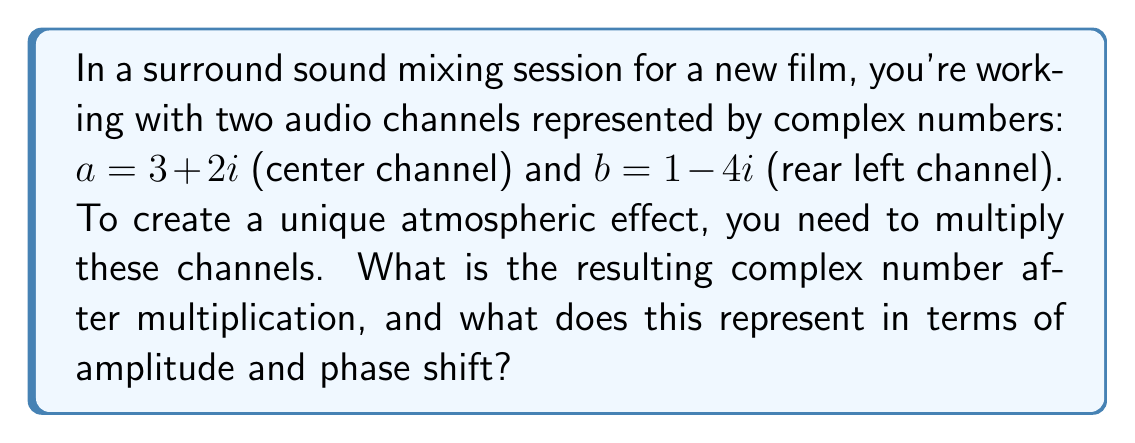Show me your answer to this math problem. Let's approach this step-by-step:

1) To multiply complex numbers, we use the distributive property and the fact that $i^2 = -1$:

   $$(a + bi)(c + di) = (ac - bd) + (ad + bc)i$$

2) In our case, $a = 3 + 2i$ and $b = 1 - 4i$. So:

   $(3 + 2i)(1 - 4i)$

3) Let's expand this:
   
   $3(1) + 3(-4i) + 2i(1) + 2i(-4i)$
   
   $= 3 - 12i + 2i - 8i^2$

4) Simplify, remembering that $i^2 = -1$:
   
   $3 - 12i + 2i + 8$
   
   $= 11 - 10i$

5) This complex number, $11 - 10i$, represents the new combined audio signal.

6) In audio terms:
   - The real part (11) represents the amplitude scaling.
   - The imaginary part (-10) represents the phase shift.

7) To find the actual amplitude (volume) and phase shift:
   
   Amplitude: $\sqrt{11^2 + (-10)^2} = \sqrt{221} \approx 14.87$
   
   Phase shift: $\tan^{-1}(\frac{-10}{11}) \approx -0.7378$ radians or -42.27°

This means the resulting audio signal is amplified by a factor of about 14.87 and shifted by approximately -42.27 degrees in phase.
Answer: $11 - 10i$ 